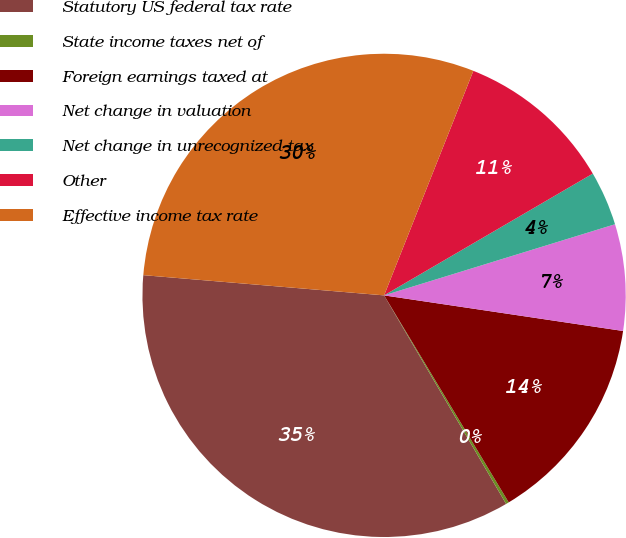Convert chart. <chart><loc_0><loc_0><loc_500><loc_500><pie_chart><fcel>Statutory US federal tax rate<fcel>State income taxes net of<fcel>Foreign earnings taxed at<fcel>Net change in valuation<fcel>Net change in unrecognized tax<fcel>Other<fcel>Effective income tax rate<nl><fcel>34.76%<fcel>0.2%<fcel>14.02%<fcel>7.11%<fcel>3.65%<fcel>10.57%<fcel>29.69%<nl></chart> 